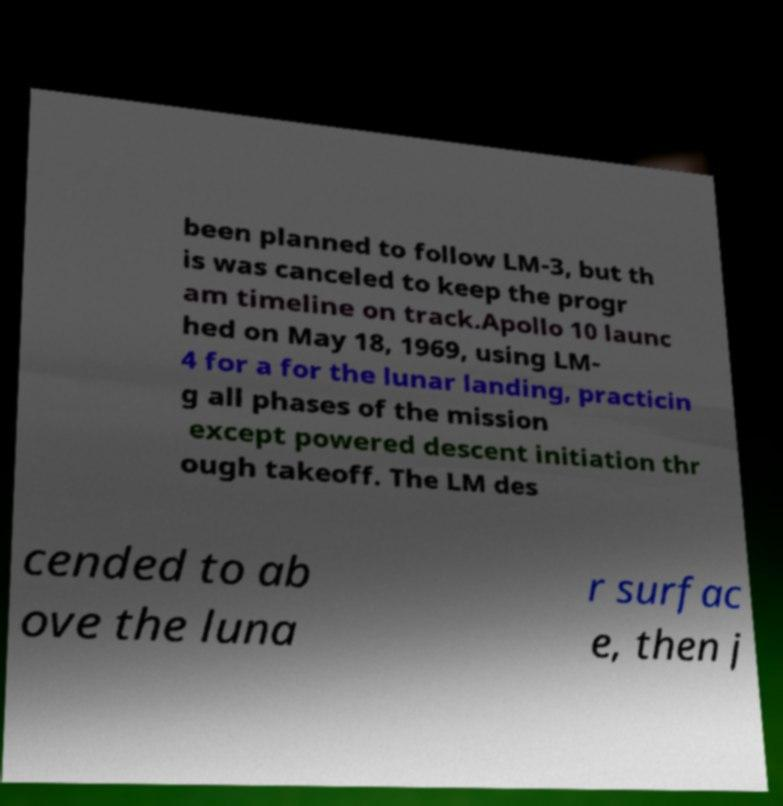Please read and relay the text visible in this image. What does it say? been planned to follow LM-3, but th is was canceled to keep the progr am timeline on track.Apollo 10 launc hed on May 18, 1969, using LM- 4 for a for the lunar landing, practicin g all phases of the mission except powered descent initiation thr ough takeoff. The LM des cended to ab ove the luna r surfac e, then j 